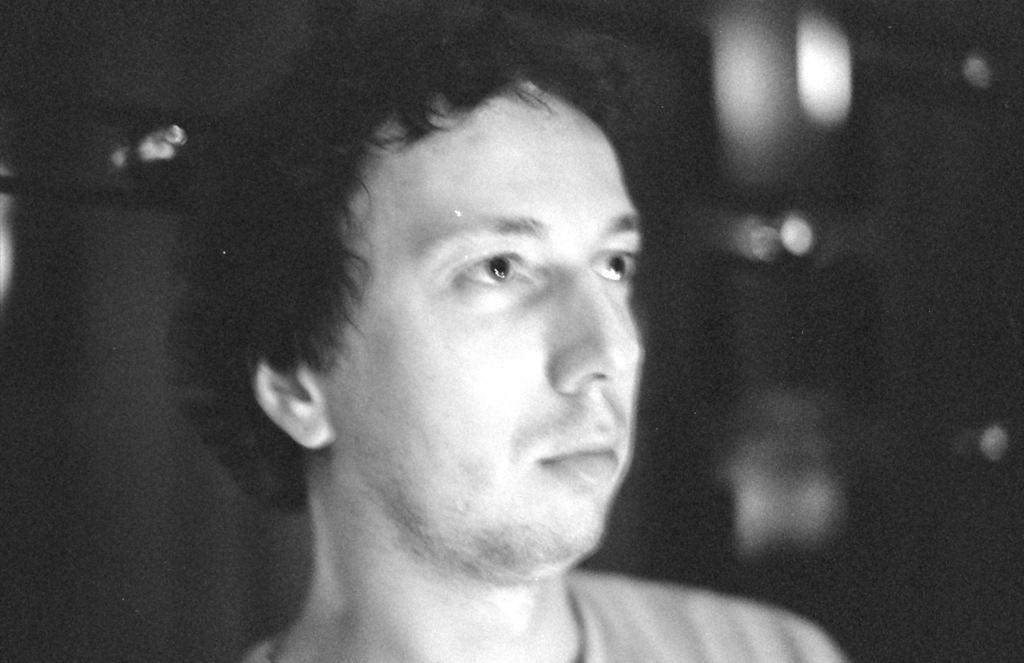What is the main subject of the image? There is a man in the center of the image. Can you describe the background of the image? The background of the image is blurry. How many chickens are present in the image? There are no chickens present in the image. What type of knot is the man tying in the image? There is no knot or tying action depicted in the image. 